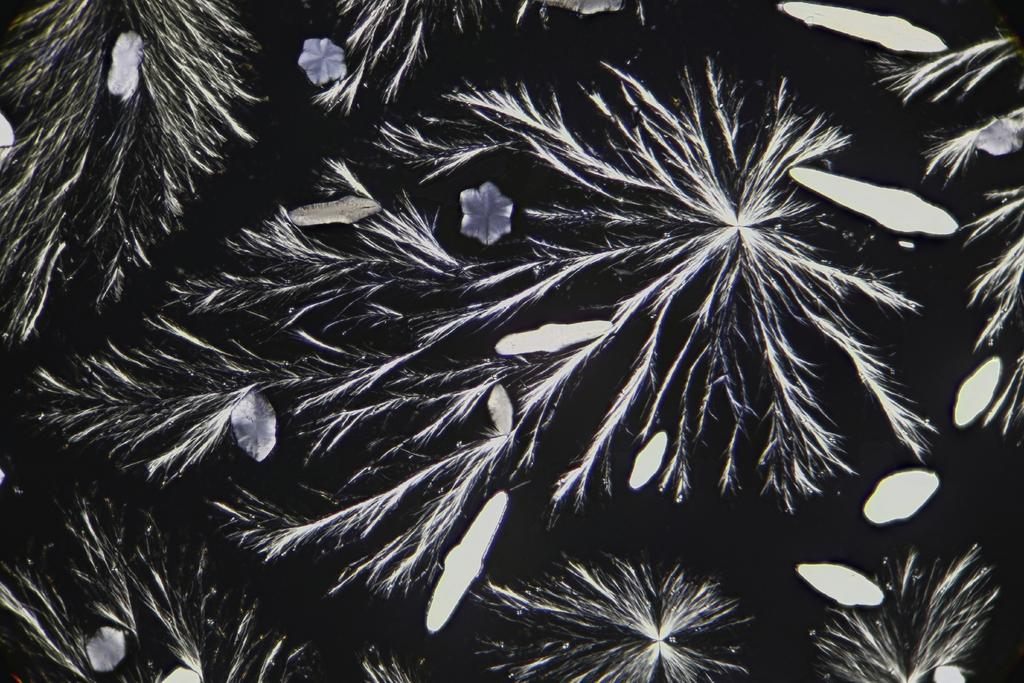What types of designs are present in the image? The image contains a design with flowers and a design with leaves. What is the color of the background in the image? The background of the image is black. How many mice can be seen in the image? There are no mice present in the image. What shape is the paper in the image? There is no paper present in the image. 